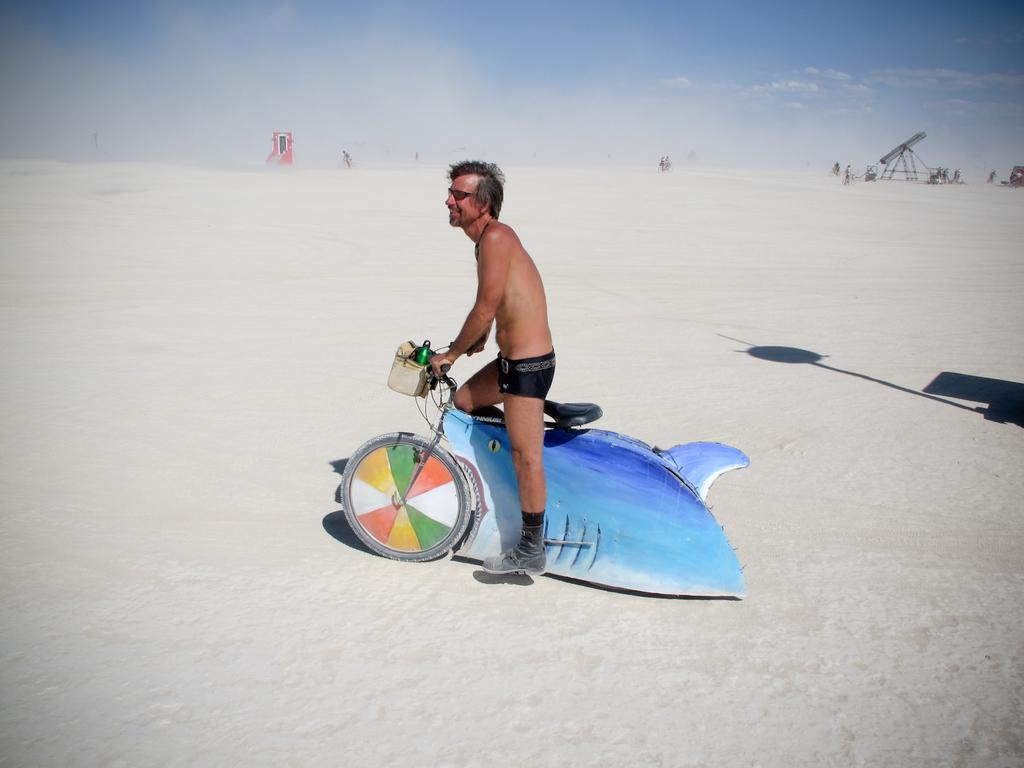Who is present in the image? There is a man in the image. What is the man doing in the image? The man is with his cycle. What is the man carrying in the image? The man is carrying a bottle in the basket of his cycle. What can be seen in the background of the image? There are people visible in the background of the image. What type of club is the man holding in the image? There is no club present in the image; the man is carrying a bottle in the basket of his cycle. How many legs does the branch have in the image? There is no branch present in the image. 